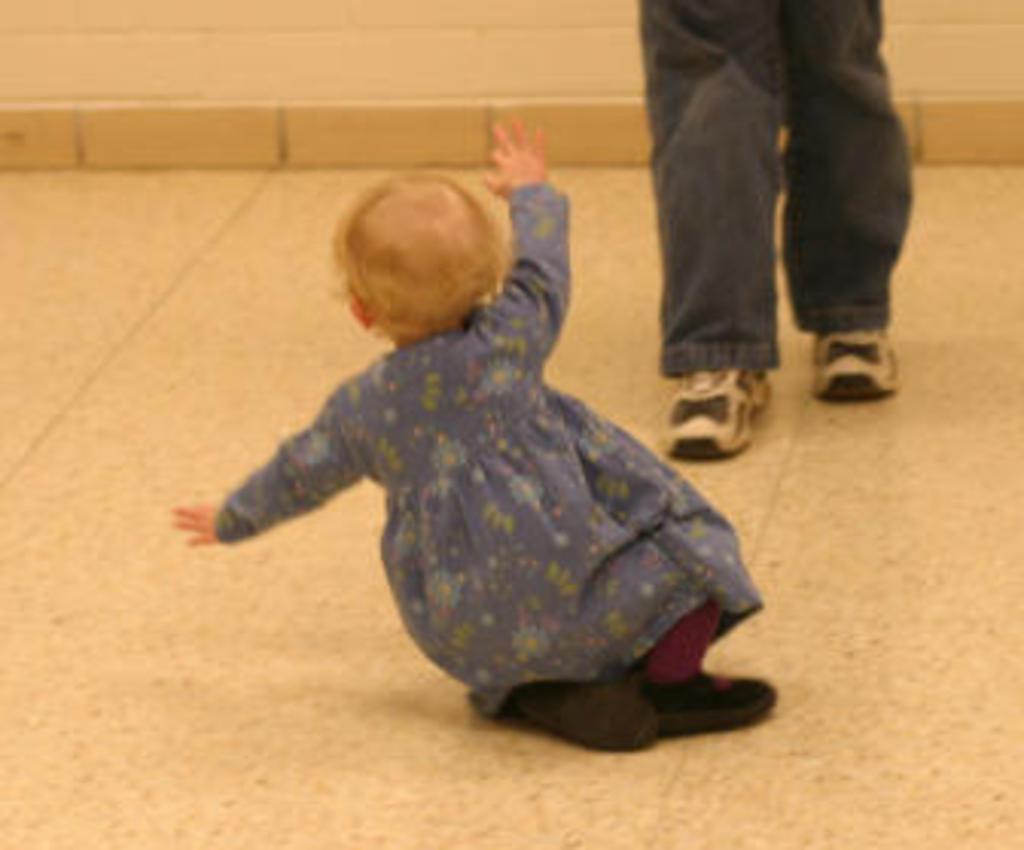Describe this image in one or two sentences. In this image I can see a baby, floor and legs of a person. 